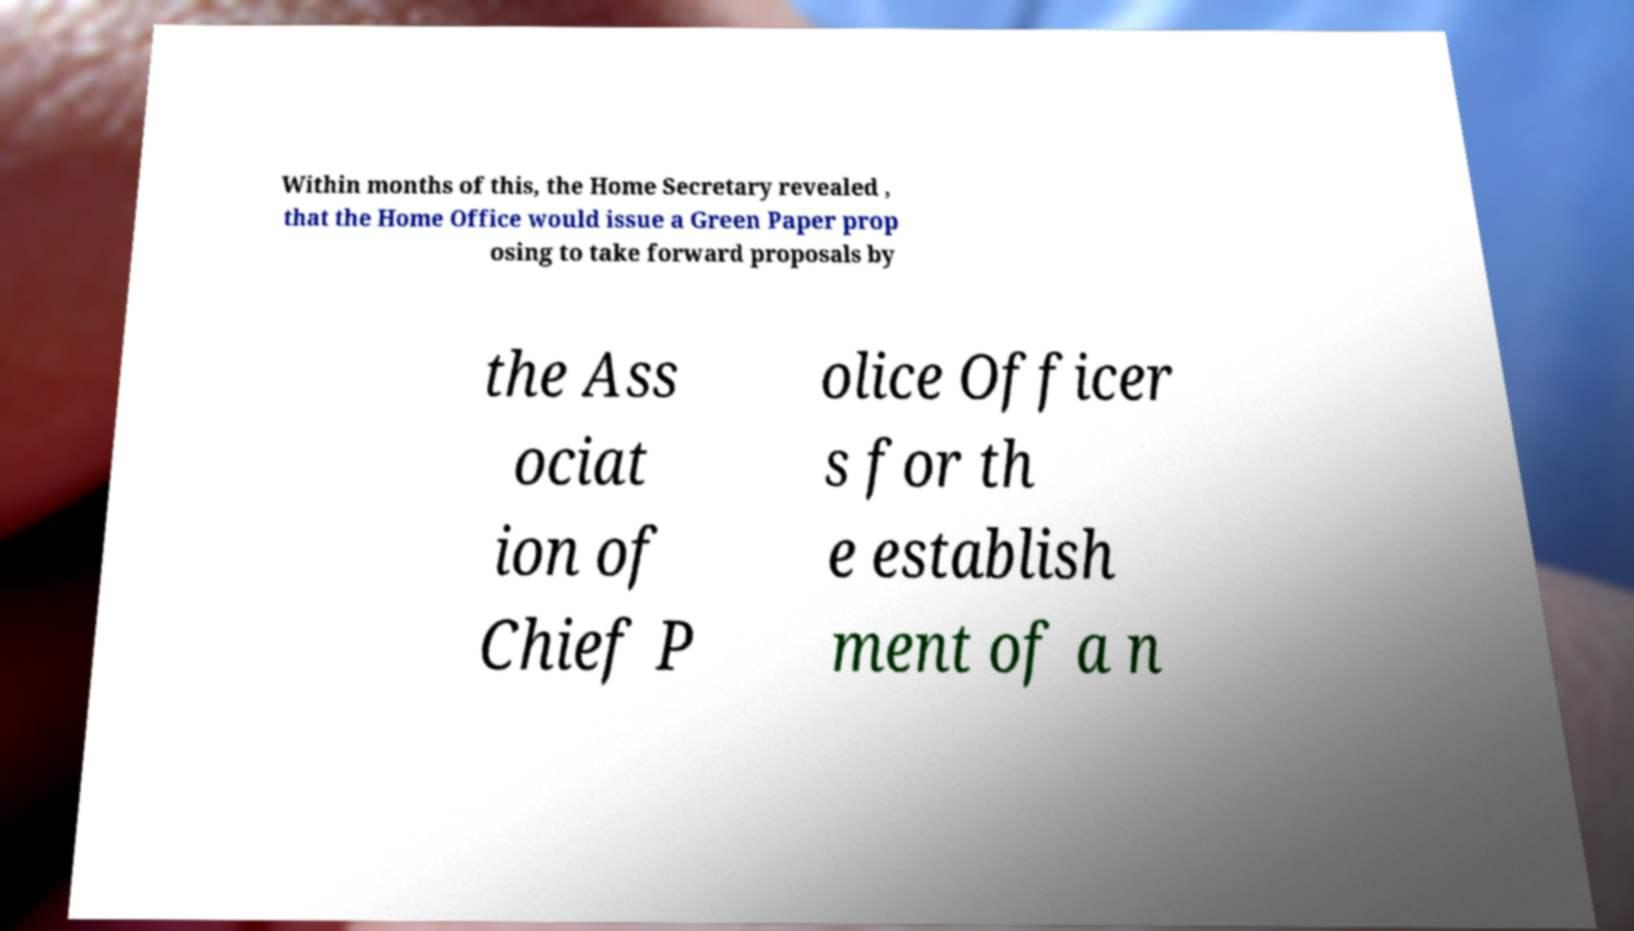I need the written content from this picture converted into text. Can you do that? Within months of this, the Home Secretary revealed , that the Home Office would issue a Green Paper prop osing to take forward proposals by the Ass ociat ion of Chief P olice Officer s for th e establish ment of a n 